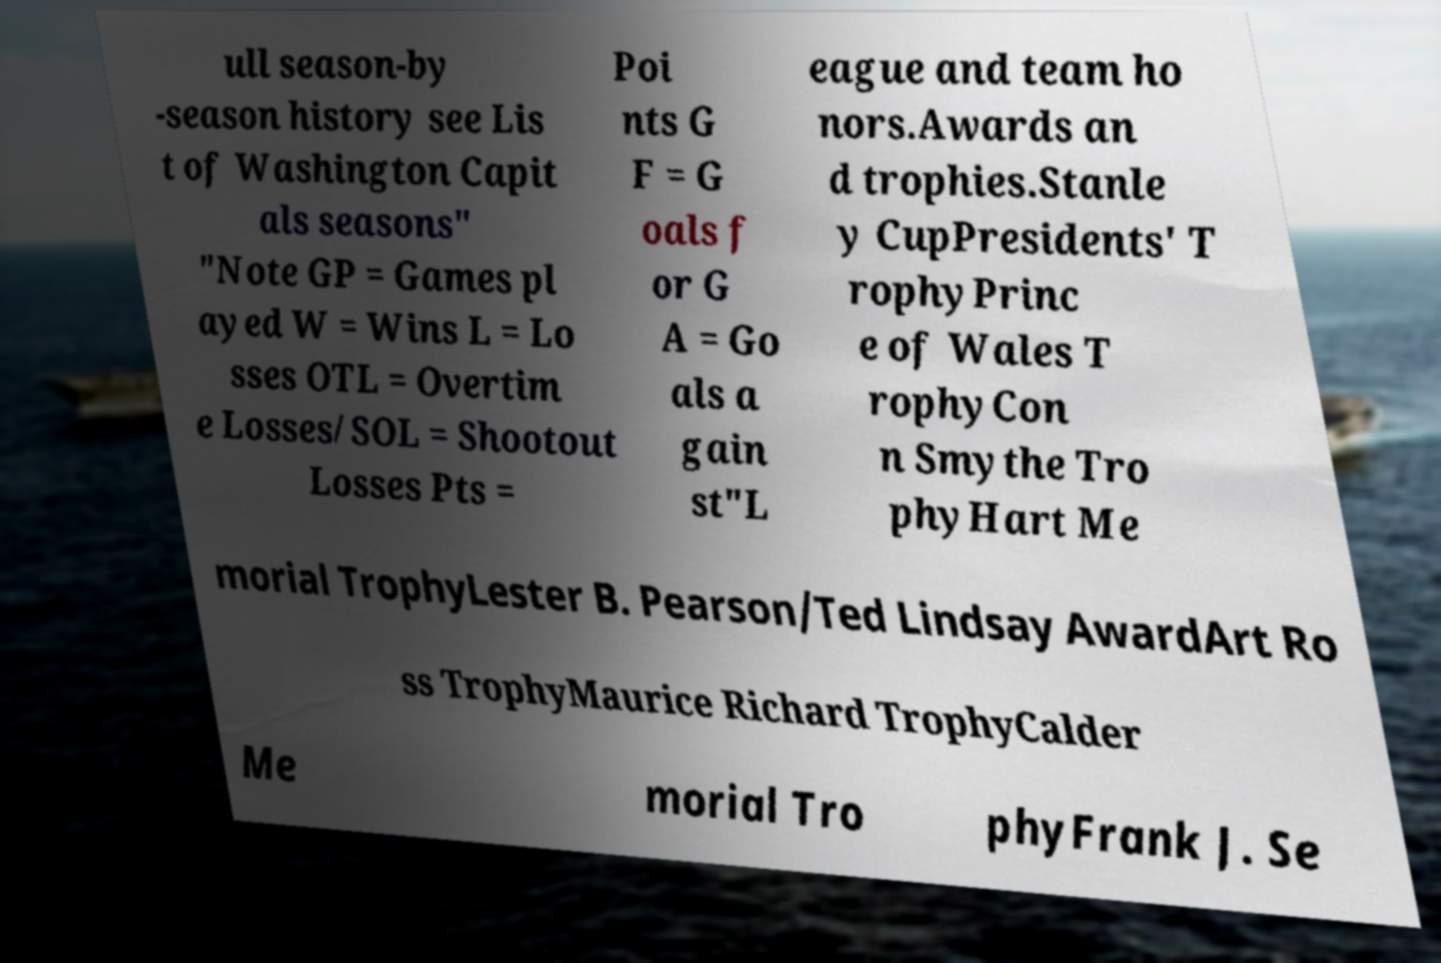There's text embedded in this image that I need extracted. Can you transcribe it verbatim? ull season-by -season history see Lis t of Washington Capit als seasons" "Note GP = Games pl ayed W = Wins L = Lo sses OTL = Overtim e Losses/SOL = Shootout Losses Pts = Poi nts G F = G oals f or G A = Go als a gain st"L eague and team ho nors.Awards an d trophies.Stanle y CupPresidents' T rophyPrinc e of Wales T rophyCon n Smythe Tro phyHart Me morial TrophyLester B. Pearson/Ted Lindsay AwardArt Ro ss TrophyMaurice Richard TrophyCalder Me morial Tro phyFrank J. Se 